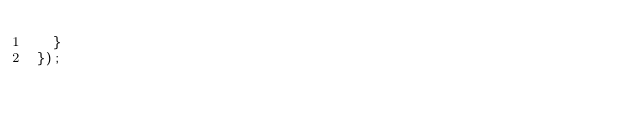<code> <loc_0><loc_0><loc_500><loc_500><_JavaScript_>	}
});</code> 